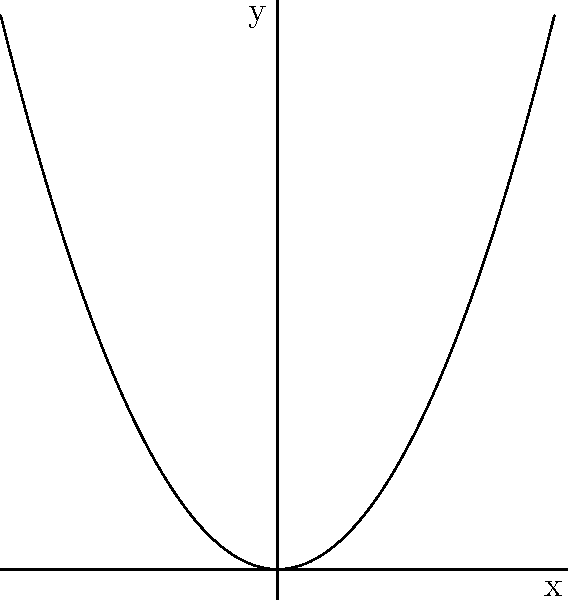As a songwriter, you often find inspiration in the shapes and curves you see around you. The graph above reminds you of a musical note. What type of conic section does this graph represent, and how might it inspire a lyrical metaphor about rising to new heights in your songwriting collaboration with Aaron Wilburn? To identify the type of conic section, let's analyze the graph step-by-step:

1. The curve opens upward and is symmetric about the y-axis.
2. It has a U-shape, which is characteristic of a parabola.
3. The equation of a parabola with a vertical axis of symmetry is of the form $y = ax^2 + bx + c$, where $a \neq 0$.
4. In this case, the vertex of the parabola is at the origin (0,0), so $b = 0$ and $c = 0$.
5. The equation of this parabola is likely $y = ax^2$, where $a > 0$ (since it opens upward).

Therefore, this graph represents a parabola.

In terms of songwriting inspiration, a parabola can be seen as a metaphor for:
- The arc of a career, starting from the bottom, rising to new heights
- The journey of personal growth and self-discovery
- The uplifting nature of music, elevating the spirit

This shape could inspire lyrics about rising above challenges, reaching for dreams, or the transformative power of music, all themes that would resonate with Aaron Wilburn's style of inspirational and uplifting songwriting.
Answer: Parabola 